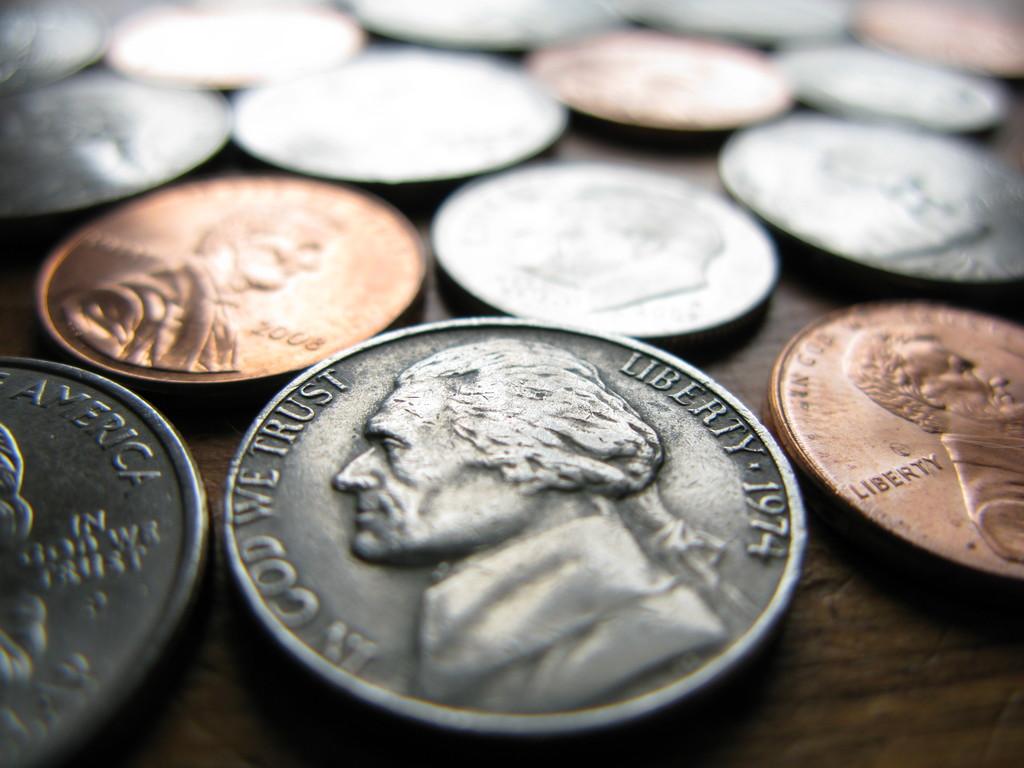What year is the biggest coin?
Offer a very short reply. 1974. 